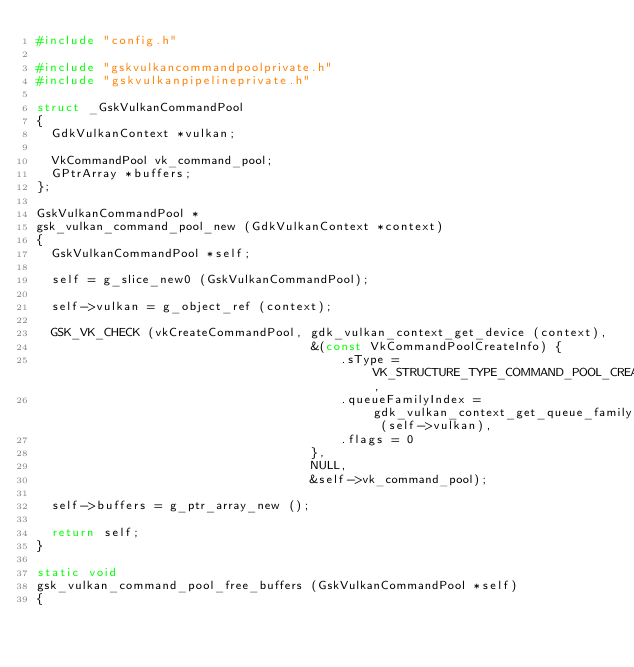Convert code to text. <code><loc_0><loc_0><loc_500><loc_500><_C_>#include "config.h"

#include "gskvulkancommandpoolprivate.h"
#include "gskvulkanpipelineprivate.h"

struct _GskVulkanCommandPool
{
  GdkVulkanContext *vulkan;

  VkCommandPool vk_command_pool;
  GPtrArray *buffers;
};

GskVulkanCommandPool *
gsk_vulkan_command_pool_new (GdkVulkanContext *context)
{
  GskVulkanCommandPool *self;

  self = g_slice_new0 (GskVulkanCommandPool);

  self->vulkan = g_object_ref (context);

  GSK_VK_CHECK (vkCreateCommandPool, gdk_vulkan_context_get_device (context),
                                     &(const VkCommandPoolCreateInfo) {
                                         .sType = VK_STRUCTURE_TYPE_COMMAND_POOL_CREATE_INFO,
                                         .queueFamilyIndex = gdk_vulkan_context_get_queue_family_index (self->vulkan),
                                         .flags = 0
                                     },
                                     NULL,
                                     &self->vk_command_pool);

  self->buffers = g_ptr_array_new ();

  return self;
}

static void
gsk_vulkan_command_pool_free_buffers (GskVulkanCommandPool *self)
{</code> 